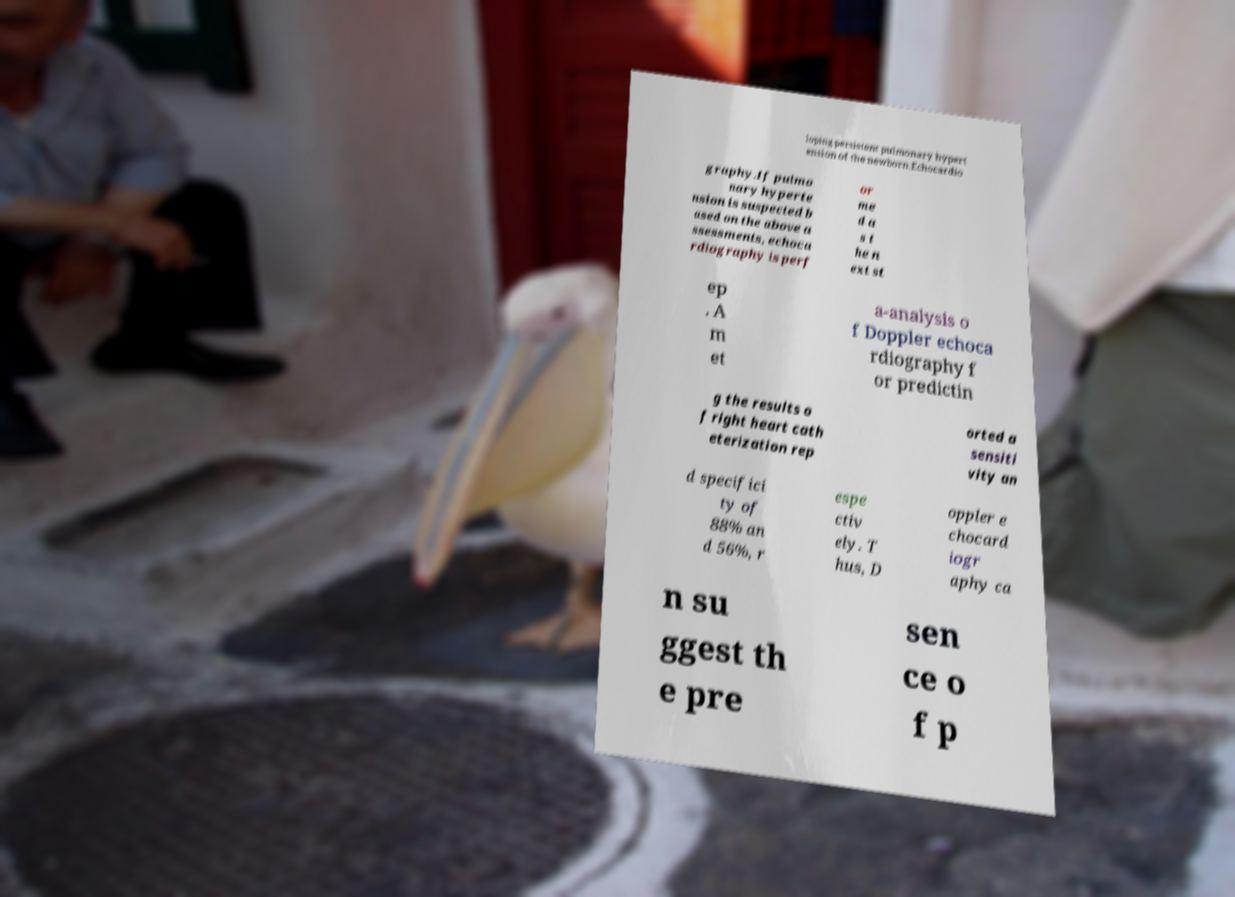Can you read and provide the text displayed in the image?This photo seems to have some interesting text. Can you extract and type it out for me? loping persistent pulmonary hypert ension of the newborn.Echocardio graphy.If pulmo nary hyperte nsion is suspected b ased on the above a ssessments, echoca rdiography is perf or me d a s t he n ext st ep . A m et a-analysis o f Doppler echoca rdiography f or predictin g the results o f right heart cath eterization rep orted a sensiti vity an d specifici ty of 88% an d 56%, r espe ctiv ely. T hus, D oppler e chocard iogr aphy ca n su ggest th e pre sen ce o f p 